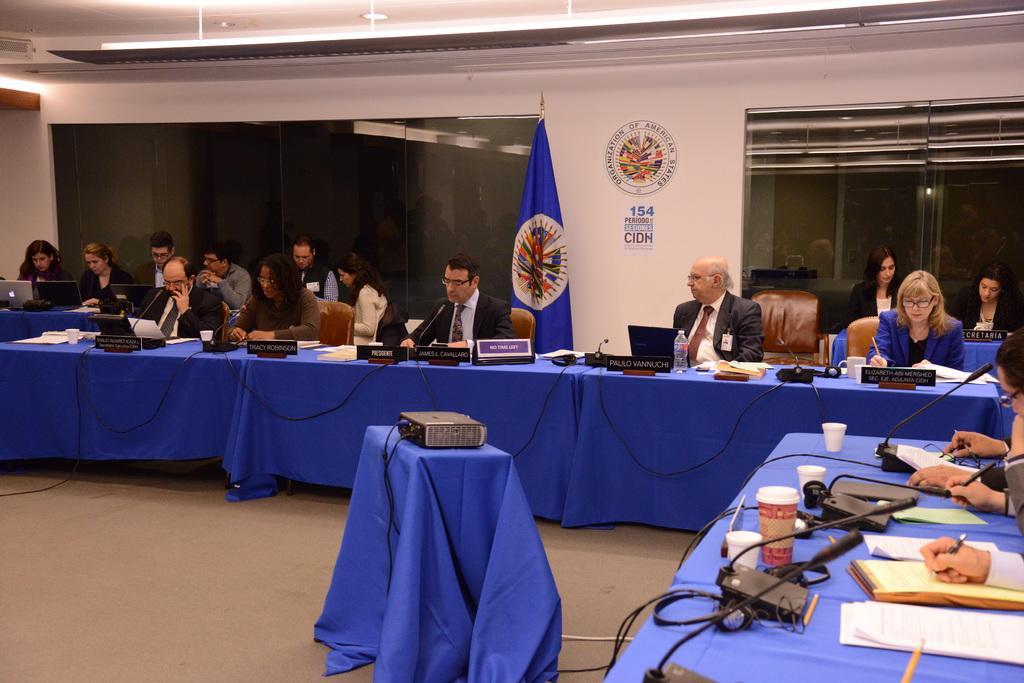How would you summarize this image in a sentence or two? This image consists of many people sitting in the chairs near the tables. The tables are covered with blue clothes. On which, we can see the mics, books, and name boards along with laptops. At the bottom, there is a floor. In the background, it looks like a flag. At the top, there is a roof. 